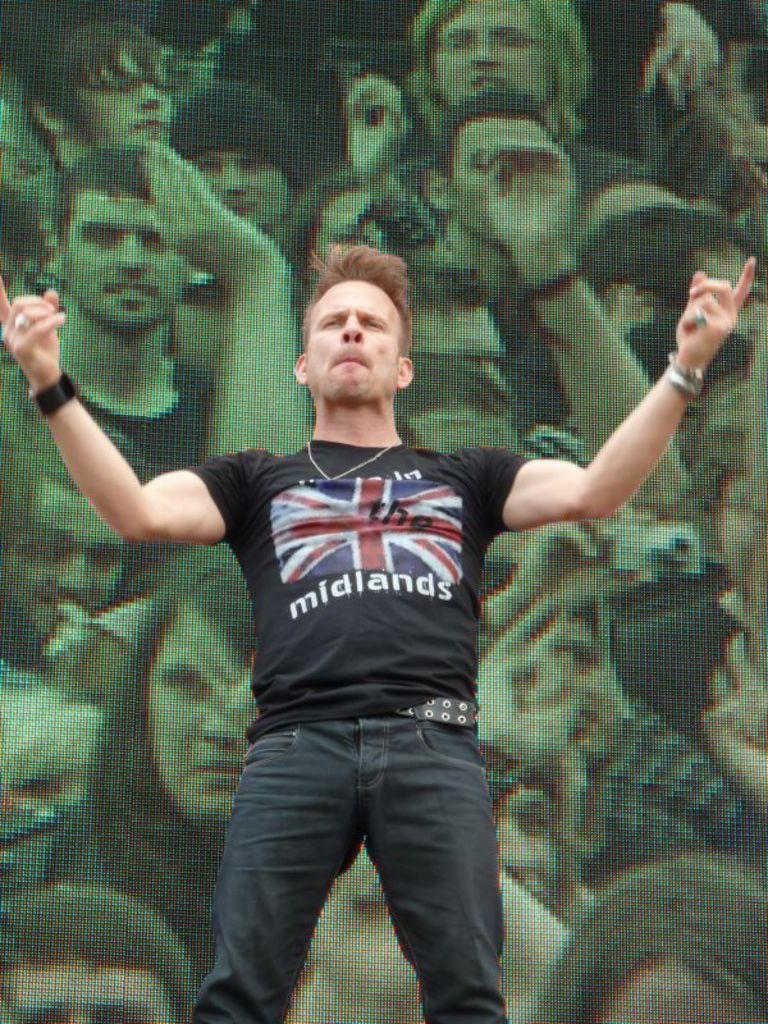Who is present in the image? There is a man in the image. What is the man doing in the image? The man is standing in front of a display. What type of pet is the man holding in the image? There is no pet present in the image; the man is standing in front of a display. 